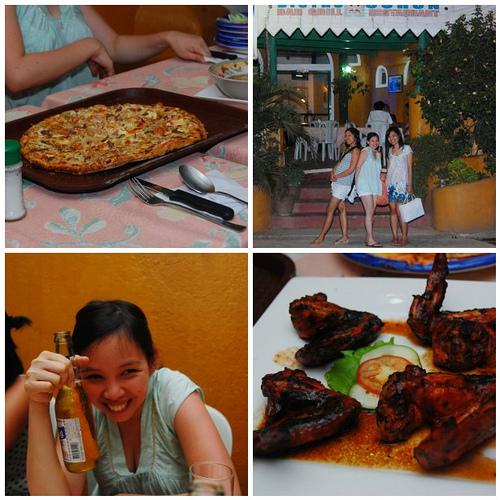Identify one piece of tableware, describe its appearance and mention its location in reference to another object. A silver fork is placed on the table and is situated close to a set of silverware with a black handle knife. Comment on the quality of the cooked food in the image, with specific reference to one of the items. The cooked food appears to be appetizing, but the chicken wings look slightly burnt. Name three objects found in the image and mention their colors. A whole pizza on a brown tray, a girl holding a clear bottle of golden yellow liquid, and a set of silverware with a black handle knife. Describe the appearance of the silverware in the image and mention its color. The silverware features a metal spoon and a metal fork, both having a silver color, along with a set of silverware with a black handle knife. What beverage is being consumed by one of the women in the image, and what container is it in? One of the women is consuming a golden yellow liquid, likely beer, from a clear glass bottle. Give a brief description of three varied food items and their containers or plates. A whole pizza on a brown tray, seasoned chicken wings on a square white plate, and a slice of a red tomato on the table. Mention the number of food items on the table and briefly describe one of them. There are five food items on the table, which includes a whole pizza with various toppings placed on a brown tray. In this image, identify a group of people and describe their appearance and actions. Three young girls are posing for a photo, they seem happy and are enjoying a good time. Identify one object that may be a part of the background or environment, describe its position in the image. Part of a plant is visible in the top right corner of the image, with its leafy green foliage in contrast to its surroundings. Describe the image's atmosphere in terms of people's emotions and interactions. The image has a joyful and friendly atmosphere, as a happy woman smiles while holding a beer, and girls pose for photos, giving the impression of a good time. Is the clear shaker with a blue lid? The clear shaker actually has a green lid as mentioned in the prompt. Is the fork made of plastic? The fork is actually made of metal as mentioned in the prompt. Are there two young girls posing for a photo? There are actually three young girls posing for a photo as mentioned in the prompt. Are there six seasoned chicken wings in the image? There are only four seasoned chicken wings in the image according to the prompt. Is the girl holding a plastic bottle? The girl is actually holding a glass bottle as mentioned in the prompt. Is the whole pizza on a blue tray? The whole pizza is actually on a brown tray as mentioned in the prompt. 